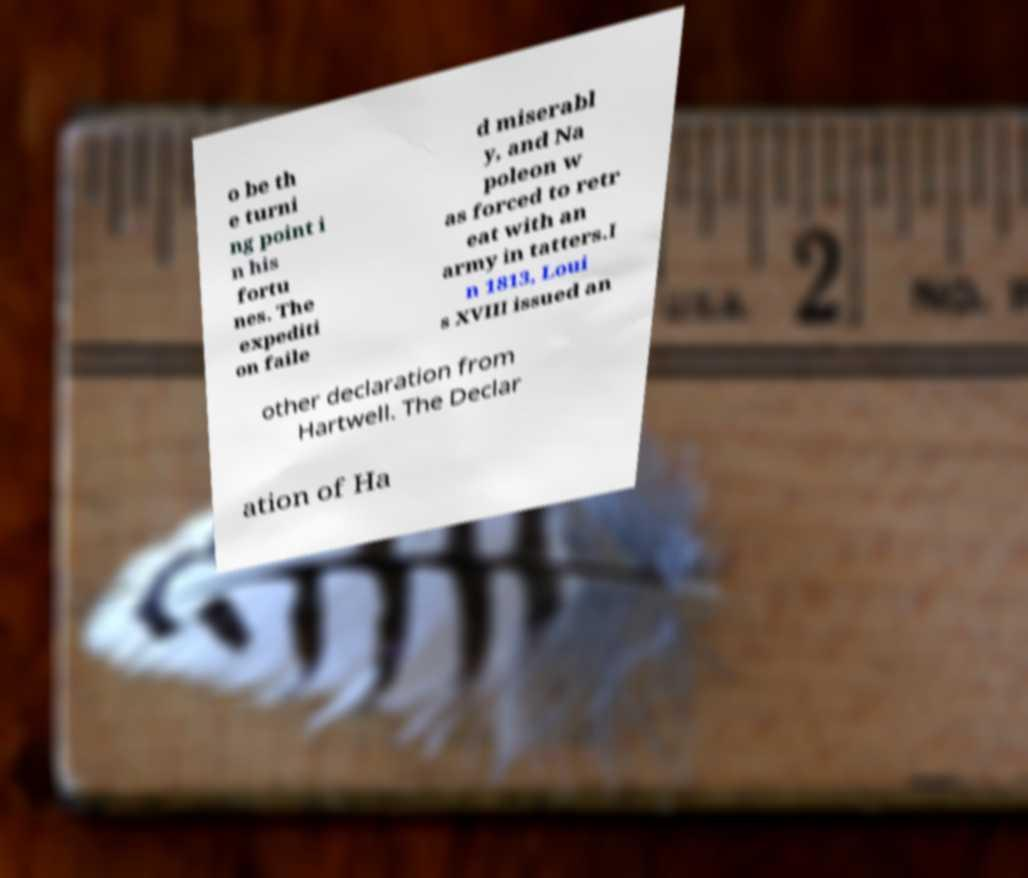There's text embedded in this image that I need extracted. Can you transcribe it verbatim? o be th e turni ng point i n his fortu nes. The expediti on faile d miserabl y, and Na poleon w as forced to retr eat with an army in tatters.I n 1813, Loui s XVIII issued an other declaration from Hartwell. The Declar ation of Ha 